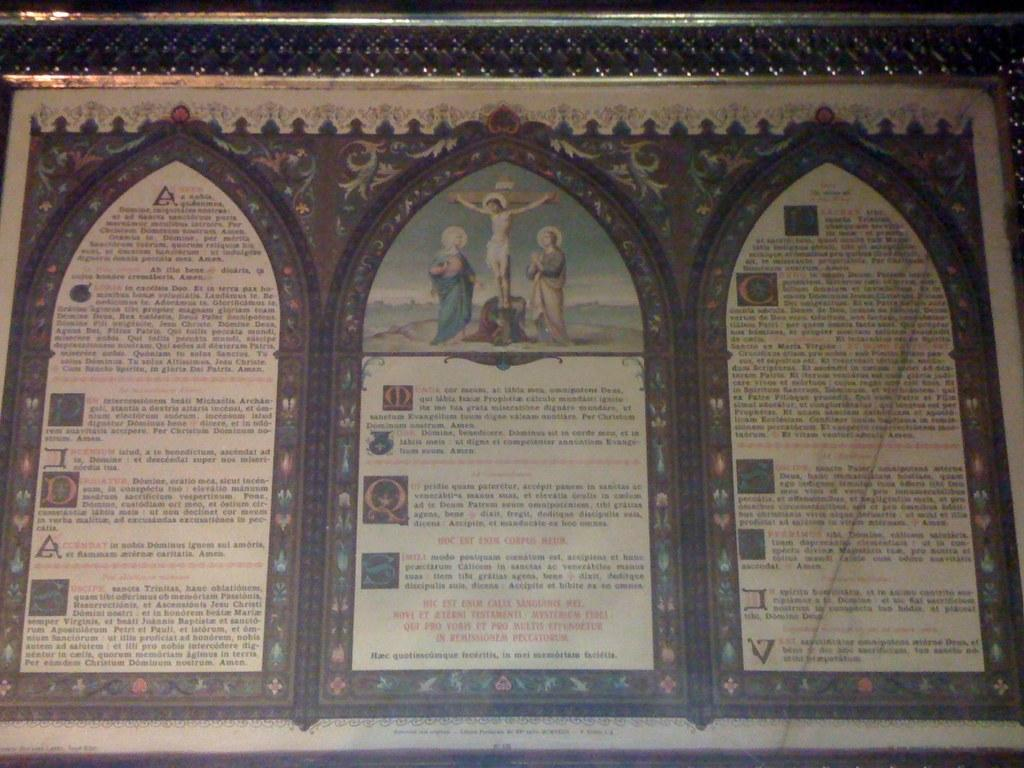What is the main object in the image? There is a photo frame in the image. What is inside the photo frame? The photo frame contains three posters. Can you describe the content of the posters? Each poster has an image and text. What is the color of the background on the posters? The background of the posters is white. How does the bomb affect the posters in the image? There is no bomb present in the image, so it cannot affect the posters. What type of arithmetic problem is being solved on the posters? The posters do not contain any arithmetic problems; they have images and text. 